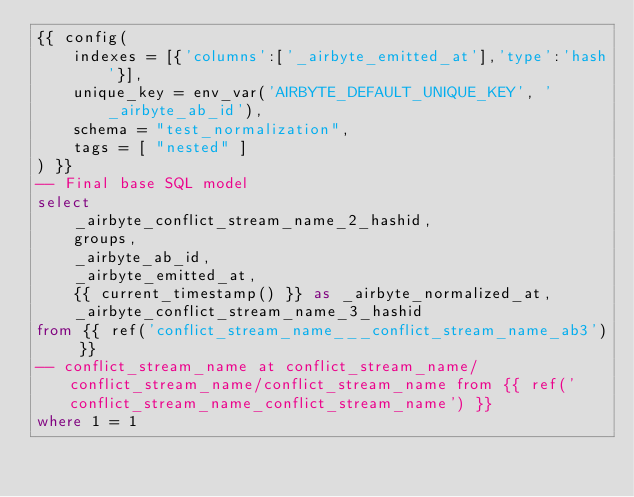Convert code to text. <code><loc_0><loc_0><loc_500><loc_500><_SQL_>{{ config(
    indexes = [{'columns':['_airbyte_emitted_at'],'type':'hash'}],
    unique_key = env_var('AIRBYTE_DEFAULT_UNIQUE_KEY', '_airbyte_ab_id'),
    schema = "test_normalization",
    tags = [ "nested" ]
) }}
-- Final base SQL model
select
    _airbyte_conflict_stream_name_2_hashid,
    groups,
    _airbyte_ab_id,
    _airbyte_emitted_at,
    {{ current_timestamp() }} as _airbyte_normalized_at,
    _airbyte_conflict_stream_name_3_hashid
from {{ ref('conflict_stream_name___conflict_stream_name_ab3') }}
-- conflict_stream_name at conflict_stream_name/conflict_stream_name/conflict_stream_name from {{ ref('conflict_stream_name_conflict_stream_name') }}
where 1 = 1

</code> 